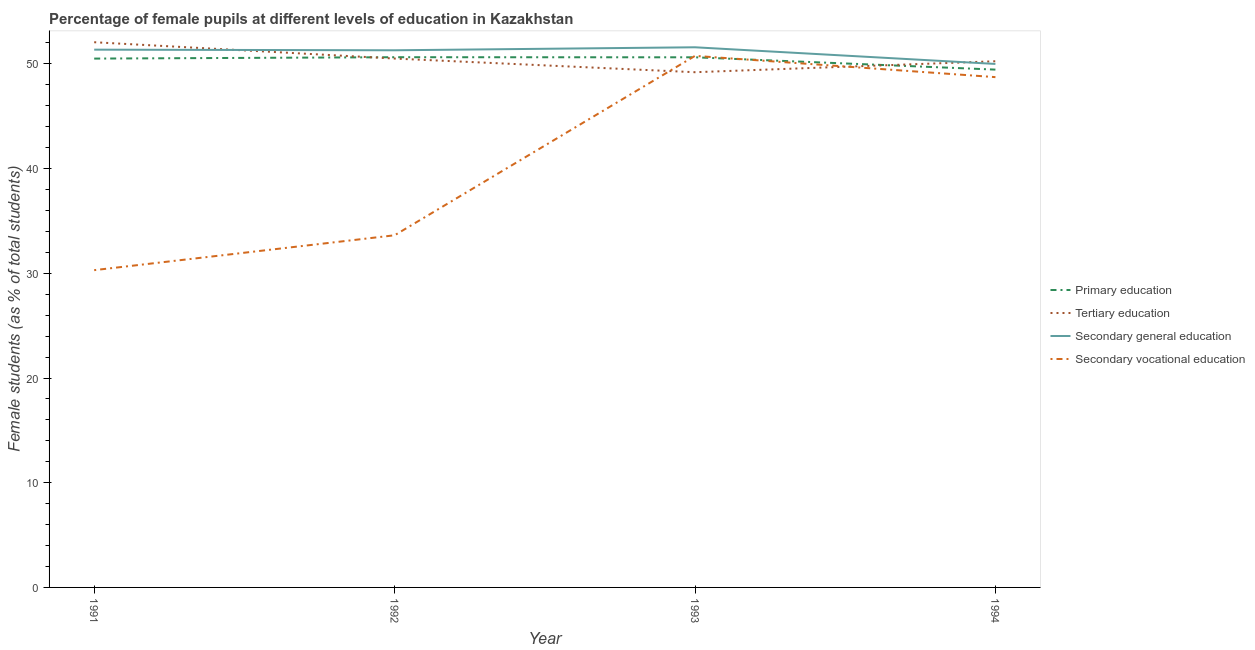How many different coloured lines are there?
Provide a short and direct response. 4. Does the line corresponding to percentage of female students in primary education intersect with the line corresponding to percentage of female students in secondary vocational education?
Your answer should be very brief. Yes. Is the number of lines equal to the number of legend labels?
Keep it short and to the point. Yes. What is the percentage of female students in primary education in 1992?
Ensure brevity in your answer.  50.64. Across all years, what is the maximum percentage of female students in primary education?
Keep it short and to the point. 50.64. Across all years, what is the minimum percentage of female students in secondary education?
Ensure brevity in your answer.  49.99. In which year was the percentage of female students in secondary vocational education minimum?
Your response must be concise. 1991. What is the total percentage of female students in secondary vocational education in the graph?
Give a very brief answer. 163.43. What is the difference between the percentage of female students in tertiary education in 1991 and that in 1992?
Provide a succinct answer. 1.56. What is the difference between the percentage of female students in secondary vocational education in 1992 and the percentage of female students in primary education in 1993?
Offer a terse response. -17. What is the average percentage of female students in secondary vocational education per year?
Give a very brief answer. 40.86. In the year 1991, what is the difference between the percentage of female students in primary education and percentage of female students in secondary vocational education?
Offer a very short reply. 20.21. In how many years, is the percentage of female students in primary education greater than 42 %?
Your answer should be compact. 4. What is the ratio of the percentage of female students in primary education in 1992 to that in 1993?
Your answer should be very brief. 1. Is the difference between the percentage of female students in secondary vocational education in 1992 and 1993 greater than the difference between the percentage of female students in tertiary education in 1992 and 1993?
Provide a succinct answer. No. What is the difference between the highest and the second highest percentage of female students in tertiary education?
Offer a very short reply. 1.56. What is the difference between the highest and the lowest percentage of female students in secondary vocational education?
Keep it short and to the point. 20.47. Is the sum of the percentage of female students in tertiary education in 1991 and 1993 greater than the maximum percentage of female students in secondary education across all years?
Provide a short and direct response. Yes. Is it the case that in every year, the sum of the percentage of female students in secondary vocational education and percentage of female students in secondary education is greater than the sum of percentage of female students in tertiary education and percentage of female students in primary education?
Offer a terse response. No. Is the percentage of female students in secondary education strictly greater than the percentage of female students in tertiary education over the years?
Provide a short and direct response. No. How many years are there in the graph?
Give a very brief answer. 4. What is the difference between two consecutive major ticks on the Y-axis?
Give a very brief answer. 10. Does the graph contain grids?
Offer a terse response. No. What is the title of the graph?
Keep it short and to the point. Percentage of female pupils at different levels of education in Kazakhstan. What is the label or title of the Y-axis?
Your answer should be very brief. Female students (as % of total students). What is the Female students (as % of total students) of Primary education in 1991?
Offer a very short reply. 50.51. What is the Female students (as % of total students) in Tertiary education in 1991?
Provide a short and direct response. 52.07. What is the Female students (as % of total students) in Secondary general education in 1991?
Ensure brevity in your answer.  51.36. What is the Female students (as % of total students) of Secondary vocational education in 1991?
Give a very brief answer. 30.3. What is the Female students (as % of total students) in Primary education in 1992?
Make the answer very short. 50.64. What is the Female students (as % of total students) of Tertiary education in 1992?
Your answer should be compact. 50.51. What is the Female students (as % of total students) of Secondary general education in 1992?
Your response must be concise. 51.3. What is the Female students (as % of total students) in Secondary vocational education in 1992?
Your answer should be compact. 33.63. What is the Female students (as % of total students) of Primary education in 1993?
Your answer should be compact. 50.63. What is the Female students (as % of total students) in Tertiary education in 1993?
Keep it short and to the point. 49.21. What is the Female students (as % of total students) of Secondary general education in 1993?
Give a very brief answer. 51.59. What is the Female students (as % of total students) of Secondary vocational education in 1993?
Give a very brief answer. 50.77. What is the Female students (as % of total students) of Primary education in 1994?
Your response must be concise. 49.45. What is the Female students (as % of total students) in Tertiary education in 1994?
Offer a very short reply. 50.25. What is the Female students (as % of total students) of Secondary general education in 1994?
Your response must be concise. 49.99. What is the Female students (as % of total students) in Secondary vocational education in 1994?
Provide a succinct answer. 48.73. Across all years, what is the maximum Female students (as % of total students) in Primary education?
Provide a short and direct response. 50.64. Across all years, what is the maximum Female students (as % of total students) in Tertiary education?
Ensure brevity in your answer.  52.07. Across all years, what is the maximum Female students (as % of total students) of Secondary general education?
Offer a terse response. 51.59. Across all years, what is the maximum Female students (as % of total students) of Secondary vocational education?
Provide a succinct answer. 50.77. Across all years, what is the minimum Female students (as % of total students) in Primary education?
Offer a very short reply. 49.45. Across all years, what is the minimum Female students (as % of total students) in Tertiary education?
Offer a very short reply. 49.21. Across all years, what is the minimum Female students (as % of total students) in Secondary general education?
Your response must be concise. 49.99. Across all years, what is the minimum Female students (as % of total students) of Secondary vocational education?
Your response must be concise. 30.3. What is the total Female students (as % of total students) of Primary education in the graph?
Your response must be concise. 201.23. What is the total Female students (as % of total students) of Tertiary education in the graph?
Offer a very short reply. 202.04. What is the total Female students (as % of total students) in Secondary general education in the graph?
Your response must be concise. 204.24. What is the total Female students (as % of total students) in Secondary vocational education in the graph?
Keep it short and to the point. 163.43. What is the difference between the Female students (as % of total students) in Primary education in 1991 and that in 1992?
Keep it short and to the point. -0.13. What is the difference between the Female students (as % of total students) of Tertiary education in 1991 and that in 1992?
Give a very brief answer. 1.56. What is the difference between the Female students (as % of total students) of Secondary general education in 1991 and that in 1992?
Your answer should be very brief. 0.06. What is the difference between the Female students (as % of total students) in Secondary vocational education in 1991 and that in 1992?
Your answer should be compact. -3.33. What is the difference between the Female students (as % of total students) in Primary education in 1991 and that in 1993?
Ensure brevity in your answer.  -0.12. What is the difference between the Female students (as % of total students) in Tertiary education in 1991 and that in 1993?
Your answer should be very brief. 2.86. What is the difference between the Female students (as % of total students) of Secondary general education in 1991 and that in 1993?
Ensure brevity in your answer.  -0.23. What is the difference between the Female students (as % of total students) in Secondary vocational education in 1991 and that in 1993?
Your answer should be very brief. -20.47. What is the difference between the Female students (as % of total students) of Primary education in 1991 and that in 1994?
Your answer should be very brief. 1.05. What is the difference between the Female students (as % of total students) of Tertiary education in 1991 and that in 1994?
Offer a terse response. 1.82. What is the difference between the Female students (as % of total students) of Secondary general education in 1991 and that in 1994?
Offer a very short reply. 1.36. What is the difference between the Female students (as % of total students) of Secondary vocational education in 1991 and that in 1994?
Your answer should be compact. -18.43. What is the difference between the Female students (as % of total students) in Primary education in 1992 and that in 1993?
Your answer should be very brief. 0.01. What is the difference between the Female students (as % of total students) in Tertiary education in 1992 and that in 1993?
Make the answer very short. 1.3. What is the difference between the Female students (as % of total students) in Secondary general education in 1992 and that in 1993?
Provide a succinct answer. -0.29. What is the difference between the Female students (as % of total students) in Secondary vocational education in 1992 and that in 1993?
Your response must be concise. -17.13. What is the difference between the Female students (as % of total students) in Primary education in 1992 and that in 1994?
Give a very brief answer. 1.18. What is the difference between the Female students (as % of total students) of Tertiary education in 1992 and that in 1994?
Provide a short and direct response. 0.26. What is the difference between the Female students (as % of total students) in Secondary general education in 1992 and that in 1994?
Give a very brief answer. 1.3. What is the difference between the Female students (as % of total students) in Secondary vocational education in 1992 and that in 1994?
Give a very brief answer. -15.1. What is the difference between the Female students (as % of total students) in Primary education in 1993 and that in 1994?
Offer a terse response. 1.18. What is the difference between the Female students (as % of total students) in Tertiary education in 1993 and that in 1994?
Make the answer very short. -1.05. What is the difference between the Female students (as % of total students) of Secondary general education in 1993 and that in 1994?
Your answer should be very brief. 1.59. What is the difference between the Female students (as % of total students) in Secondary vocational education in 1993 and that in 1994?
Your response must be concise. 2.03. What is the difference between the Female students (as % of total students) in Primary education in 1991 and the Female students (as % of total students) in Tertiary education in 1992?
Offer a very short reply. -0. What is the difference between the Female students (as % of total students) in Primary education in 1991 and the Female students (as % of total students) in Secondary general education in 1992?
Make the answer very short. -0.79. What is the difference between the Female students (as % of total students) of Primary education in 1991 and the Female students (as % of total students) of Secondary vocational education in 1992?
Ensure brevity in your answer.  16.87. What is the difference between the Female students (as % of total students) in Tertiary education in 1991 and the Female students (as % of total students) in Secondary general education in 1992?
Provide a succinct answer. 0.77. What is the difference between the Female students (as % of total students) of Tertiary education in 1991 and the Female students (as % of total students) of Secondary vocational education in 1992?
Ensure brevity in your answer.  18.44. What is the difference between the Female students (as % of total students) of Secondary general education in 1991 and the Female students (as % of total students) of Secondary vocational education in 1992?
Provide a succinct answer. 17.73. What is the difference between the Female students (as % of total students) of Primary education in 1991 and the Female students (as % of total students) of Tertiary education in 1993?
Keep it short and to the point. 1.3. What is the difference between the Female students (as % of total students) of Primary education in 1991 and the Female students (as % of total students) of Secondary general education in 1993?
Provide a succinct answer. -1.08. What is the difference between the Female students (as % of total students) of Primary education in 1991 and the Female students (as % of total students) of Secondary vocational education in 1993?
Give a very brief answer. -0.26. What is the difference between the Female students (as % of total students) of Tertiary education in 1991 and the Female students (as % of total students) of Secondary general education in 1993?
Give a very brief answer. 0.48. What is the difference between the Female students (as % of total students) in Tertiary education in 1991 and the Female students (as % of total students) in Secondary vocational education in 1993?
Your answer should be compact. 1.3. What is the difference between the Female students (as % of total students) of Secondary general education in 1991 and the Female students (as % of total students) of Secondary vocational education in 1993?
Provide a succinct answer. 0.59. What is the difference between the Female students (as % of total students) in Primary education in 1991 and the Female students (as % of total students) in Tertiary education in 1994?
Make the answer very short. 0.25. What is the difference between the Female students (as % of total students) in Primary education in 1991 and the Female students (as % of total students) in Secondary general education in 1994?
Provide a short and direct response. 0.51. What is the difference between the Female students (as % of total students) of Primary education in 1991 and the Female students (as % of total students) of Secondary vocational education in 1994?
Offer a very short reply. 1.77. What is the difference between the Female students (as % of total students) in Tertiary education in 1991 and the Female students (as % of total students) in Secondary general education in 1994?
Your answer should be very brief. 2.07. What is the difference between the Female students (as % of total students) of Tertiary education in 1991 and the Female students (as % of total students) of Secondary vocational education in 1994?
Your answer should be compact. 3.33. What is the difference between the Female students (as % of total students) in Secondary general education in 1991 and the Female students (as % of total students) in Secondary vocational education in 1994?
Your response must be concise. 2.62. What is the difference between the Female students (as % of total students) of Primary education in 1992 and the Female students (as % of total students) of Tertiary education in 1993?
Your answer should be compact. 1.43. What is the difference between the Female students (as % of total students) in Primary education in 1992 and the Female students (as % of total students) in Secondary general education in 1993?
Give a very brief answer. -0.95. What is the difference between the Female students (as % of total students) in Primary education in 1992 and the Female students (as % of total students) in Secondary vocational education in 1993?
Offer a terse response. -0.13. What is the difference between the Female students (as % of total students) in Tertiary education in 1992 and the Female students (as % of total students) in Secondary general education in 1993?
Offer a terse response. -1.08. What is the difference between the Female students (as % of total students) in Tertiary education in 1992 and the Female students (as % of total students) in Secondary vocational education in 1993?
Offer a terse response. -0.26. What is the difference between the Female students (as % of total students) in Secondary general education in 1992 and the Female students (as % of total students) in Secondary vocational education in 1993?
Ensure brevity in your answer.  0.53. What is the difference between the Female students (as % of total students) in Primary education in 1992 and the Female students (as % of total students) in Tertiary education in 1994?
Keep it short and to the point. 0.39. What is the difference between the Female students (as % of total students) of Primary education in 1992 and the Female students (as % of total students) of Secondary general education in 1994?
Provide a succinct answer. 0.64. What is the difference between the Female students (as % of total students) of Primary education in 1992 and the Female students (as % of total students) of Secondary vocational education in 1994?
Make the answer very short. 1.9. What is the difference between the Female students (as % of total students) of Tertiary education in 1992 and the Female students (as % of total students) of Secondary general education in 1994?
Your answer should be very brief. 0.52. What is the difference between the Female students (as % of total students) in Tertiary education in 1992 and the Female students (as % of total students) in Secondary vocational education in 1994?
Your answer should be compact. 1.77. What is the difference between the Female students (as % of total students) in Secondary general education in 1992 and the Female students (as % of total students) in Secondary vocational education in 1994?
Give a very brief answer. 2.56. What is the difference between the Female students (as % of total students) of Primary education in 1993 and the Female students (as % of total students) of Tertiary education in 1994?
Your answer should be compact. 0.38. What is the difference between the Female students (as % of total students) in Primary education in 1993 and the Female students (as % of total students) in Secondary general education in 1994?
Give a very brief answer. 0.63. What is the difference between the Female students (as % of total students) in Primary education in 1993 and the Female students (as % of total students) in Secondary vocational education in 1994?
Your response must be concise. 1.89. What is the difference between the Female students (as % of total students) in Tertiary education in 1993 and the Female students (as % of total students) in Secondary general education in 1994?
Offer a very short reply. -0.79. What is the difference between the Female students (as % of total students) of Tertiary education in 1993 and the Female students (as % of total students) of Secondary vocational education in 1994?
Your response must be concise. 0.47. What is the difference between the Female students (as % of total students) of Secondary general education in 1993 and the Female students (as % of total students) of Secondary vocational education in 1994?
Offer a terse response. 2.85. What is the average Female students (as % of total students) of Primary education per year?
Offer a very short reply. 50.31. What is the average Female students (as % of total students) in Tertiary education per year?
Offer a very short reply. 50.51. What is the average Female students (as % of total students) in Secondary general education per year?
Provide a succinct answer. 51.06. What is the average Female students (as % of total students) in Secondary vocational education per year?
Provide a succinct answer. 40.86. In the year 1991, what is the difference between the Female students (as % of total students) in Primary education and Female students (as % of total students) in Tertiary education?
Offer a very short reply. -1.56. In the year 1991, what is the difference between the Female students (as % of total students) of Primary education and Female students (as % of total students) of Secondary general education?
Your answer should be compact. -0.85. In the year 1991, what is the difference between the Female students (as % of total students) in Primary education and Female students (as % of total students) in Secondary vocational education?
Make the answer very short. 20.21. In the year 1991, what is the difference between the Female students (as % of total students) in Tertiary education and Female students (as % of total students) in Secondary general education?
Make the answer very short. 0.71. In the year 1991, what is the difference between the Female students (as % of total students) in Tertiary education and Female students (as % of total students) in Secondary vocational education?
Offer a very short reply. 21.77. In the year 1991, what is the difference between the Female students (as % of total students) of Secondary general education and Female students (as % of total students) of Secondary vocational education?
Provide a succinct answer. 21.06. In the year 1992, what is the difference between the Female students (as % of total students) of Primary education and Female students (as % of total students) of Tertiary education?
Your answer should be very brief. 0.13. In the year 1992, what is the difference between the Female students (as % of total students) of Primary education and Female students (as % of total students) of Secondary general education?
Offer a terse response. -0.66. In the year 1992, what is the difference between the Female students (as % of total students) of Primary education and Female students (as % of total students) of Secondary vocational education?
Give a very brief answer. 17.01. In the year 1992, what is the difference between the Female students (as % of total students) of Tertiary education and Female students (as % of total students) of Secondary general education?
Give a very brief answer. -0.79. In the year 1992, what is the difference between the Female students (as % of total students) in Tertiary education and Female students (as % of total students) in Secondary vocational education?
Make the answer very short. 16.88. In the year 1992, what is the difference between the Female students (as % of total students) of Secondary general education and Female students (as % of total students) of Secondary vocational education?
Provide a short and direct response. 17.67. In the year 1993, what is the difference between the Female students (as % of total students) of Primary education and Female students (as % of total students) of Tertiary education?
Ensure brevity in your answer.  1.42. In the year 1993, what is the difference between the Female students (as % of total students) of Primary education and Female students (as % of total students) of Secondary general education?
Offer a very short reply. -0.96. In the year 1993, what is the difference between the Female students (as % of total students) in Primary education and Female students (as % of total students) in Secondary vocational education?
Ensure brevity in your answer.  -0.14. In the year 1993, what is the difference between the Female students (as % of total students) in Tertiary education and Female students (as % of total students) in Secondary general education?
Your response must be concise. -2.38. In the year 1993, what is the difference between the Female students (as % of total students) of Tertiary education and Female students (as % of total students) of Secondary vocational education?
Make the answer very short. -1.56. In the year 1993, what is the difference between the Female students (as % of total students) of Secondary general education and Female students (as % of total students) of Secondary vocational education?
Your response must be concise. 0.82. In the year 1994, what is the difference between the Female students (as % of total students) in Primary education and Female students (as % of total students) in Tertiary education?
Keep it short and to the point. -0.8. In the year 1994, what is the difference between the Female students (as % of total students) in Primary education and Female students (as % of total students) in Secondary general education?
Keep it short and to the point. -0.54. In the year 1994, what is the difference between the Female students (as % of total students) in Primary education and Female students (as % of total students) in Secondary vocational education?
Give a very brief answer. 0.72. In the year 1994, what is the difference between the Female students (as % of total students) of Tertiary education and Female students (as % of total students) of Secondary general education?
Give a very brief answer. 0.26. In the year 1994, what is the difference between the Female students (as % of total students) of Tertiary education and Female students (as % of total students) of Secondary vocational education?
Keep it short and to the point. 1.52. In the year 1994, what is the difference between the Female students (as % of total students) of Secondary general education and Female students (as % of total students) of Secondary vocational education?
Offer a terse response. 1.26. What is the ratio of the Female students (as % of total students) in Primary education in 1991 to that in 1992?
Your answer should be compact. 1. What is the ratio of the Female students (as % of total students) of Tertiary education in 1991 to that in 1992?
Ensure brevity in your answer.  1.03. What is the ratio of the Female students (as % of total students) in Secondary vocational education in 1991 to that in 1992?
Your response must be concise. 0.9. What is the ratio of the Female students (as % of total students) of Primary education in 1991 to that in 1993?
Give a very brief answer. 1. What is the ratio of the Female students (as % of total students) in Tertiary education in 1991 to that in 1993?
Offer a terse response. 1.06. What is the ratio of the Female students (as % of total students) in Secondary general education in 1991 to that in 1993?
Make the answer very short. 1. What is the ratio of the Female students (as % of total students) in Secondary vocational education in 1991 to that in 1993?
Make the answer very short. 0.6. What is the ratio of the Female students (as % of total students) in Primary education in 1991 to that in 1994?
Keep it short and to the point. 1.02. What is the ratio of the Female students (as % of total students) of Tertiary education in 1991 to that in 1994?
Your answer should be compact. 1.04. What is the ratio of the Female students (as % of total students) of Secondary general education in 1991 to that in 1994?
Keep it short and to the point. 1.03. What is the ratio of the Female students (as % of total students) of Secondary vocational education in 1991 to that in 1994?
Ensure brevity in your answer.  0.62. What is the ratio of the Female students (as % of total students) of Tertiary education in 1992 to that in 1993?
Provide a succinct answer. 1.03. What is the ratio of the Female students (as % of total students) in Secondary general education in 1992 to that in 1993?
Keep it short and to the point. 0.99. What is the ratio of the Female students (as % of total students) in Secondary vocational education in 1992 to that in 1993?
Keep it short and to the point. 0.66. What is the ratio of the Female students (as % of total students) in Primary education in 1992 to that in 1994?
Your response must be concise. 1.02. What is the ratio of the Female students (as % of total students) in Tertiary education in 1992 to that in 1994?
Provide a succinct answer. 1.01. What is the ratio of the Female students (as % of total students) of Secondary general education in 1992 to that in 1994?
Provide a succinct answer. 1.03. What is the ratio of the Female students (as % of total students) in Secondary vocational education in 1992 to that in 1994?
Give a very brief answer. 0.69. What is the ratio of the Female students (as % of total students) of Primary education in 1993 to that in 1994?
Make the answer very short. 1.02. What is the ratio of the Female students (as % of total students) of Tertiary education in 1993 to that in 1994?
Provide a short and direct response. 0.98. What is the ratio of the Female students (as % of total students) of Secondary general education in 1993 to that in 1994?
Provide a short and direct response. 1.03. What is the ratio of the Female students (as % of total students) of Secondary vocational education in 1993 to that in 1994?
Make the answer very short. 1.04. What is the difference between the highest and the second highest Female students (as % of total students) in Primary education?
Give a very brief answer. 0.01. What is the difference between the highest and the second highest Female students (as % of total students) of Tertiary education?
Offer a very short reply. 1.56. What is the difference between the highest and the second highest Female students (as % of total students) of Secondary general education?
Make the answer very short. 0.23. What is the difference between the highest and the second highest Female students (as % of total students) of Secondary vocational education?
Offer a very short reply. 2.03. What is the difference between the highest and the lowest Female students (as % of total students) in Primary education?
Make the answer very short. 1.18. What is the difference between the highest and the lowest Female students (as % of total students) of Tertiary education?
Your answer should be very brief. 2.86. What is the difference between the highest and the lowest Female students (as % of total students) in Secondary general education?
Keep it short and to the point. 1.59. What is the difference between the highest and the lowest Female students (as % of total students) in Secondary vocational education?
Offer a very short reply. 20.47. 